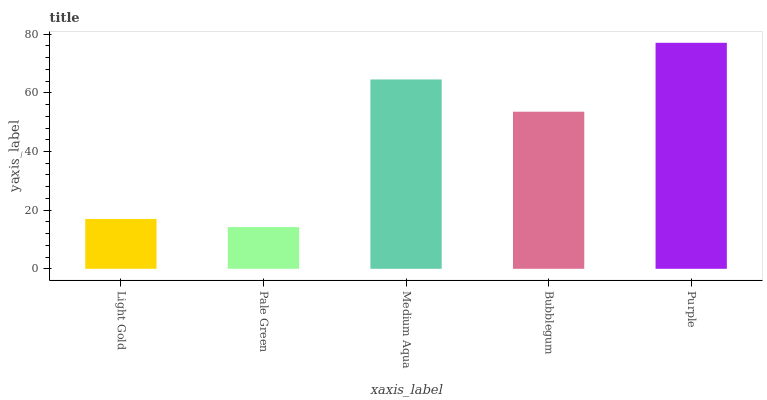Is Pale Green the minimum?
Answer yes or no. Yes. Is Purple the maximum?
Answer yes or no. Yes. Is Medium Aqua the minimum?
Answer yes or no. No. Is Medium Aqua the maximum?
Answer yes or no. No. Is Medium Aqua greater than Pale Green?
Answer yes or no. Yes. Is Pale Green less than Medium Aqua?
Answer yes or no. Yes. Is Pale Green greater than Medium Aqua?
Answer yes or no. No. Is Medium Aqua less than Pale Green?
Answer yes or no. No. Is Bubblegum the high median?
Answer yes or no. Yes. Is Bubblegum the low median?
Answer yes or no. Yes. Is Medium Aqua the high median?
Answer yes or no. No. Is Medium Aqua the low median?
Answer yes or no. No. 